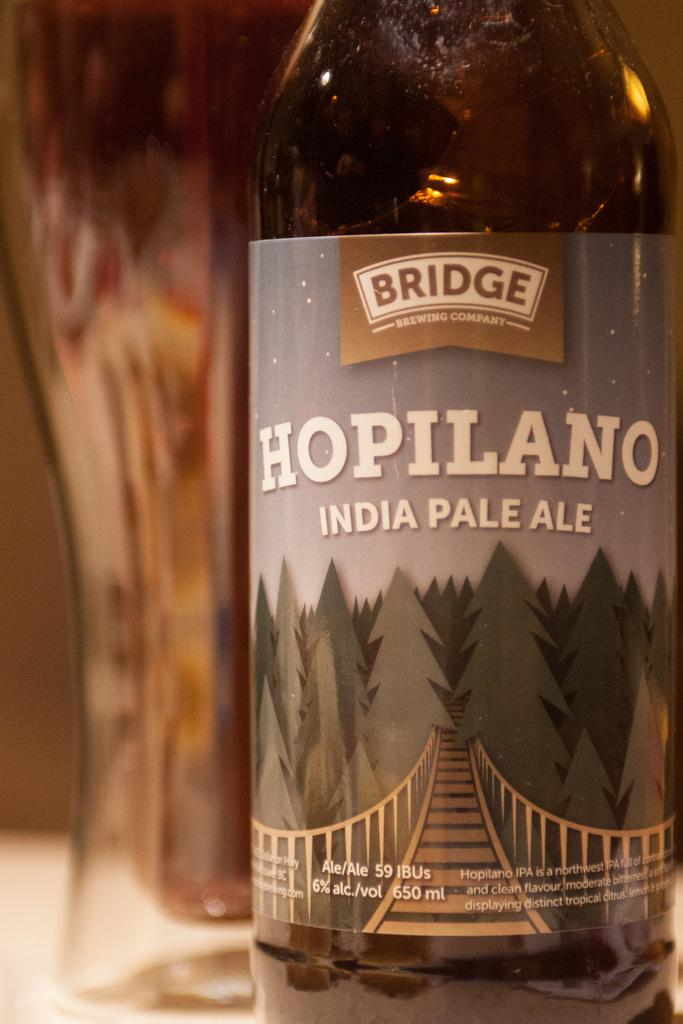Provide a one-sentence caption for the provided image. A bottle of Bridge brewing company Hopilano India Pale Ale on a table. 